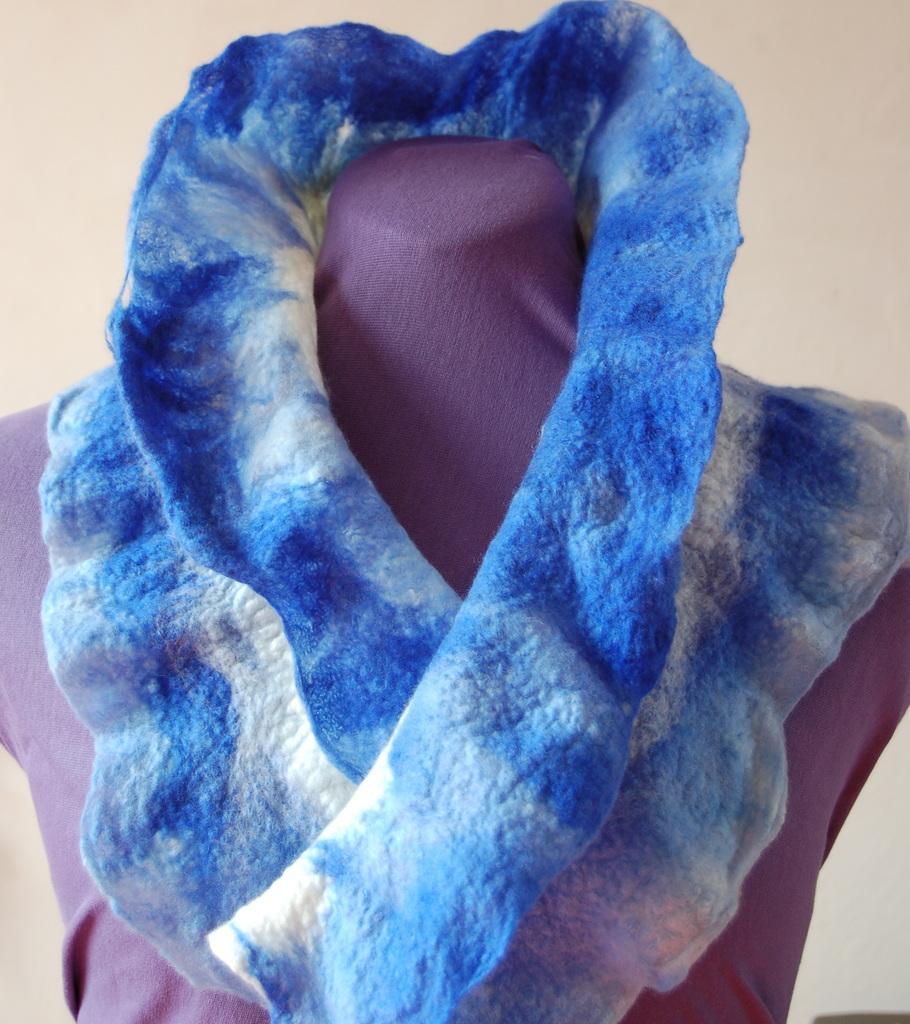Describe this image in one or two sentences. In this image, we can see a dress on the statue and we can see the white background. 